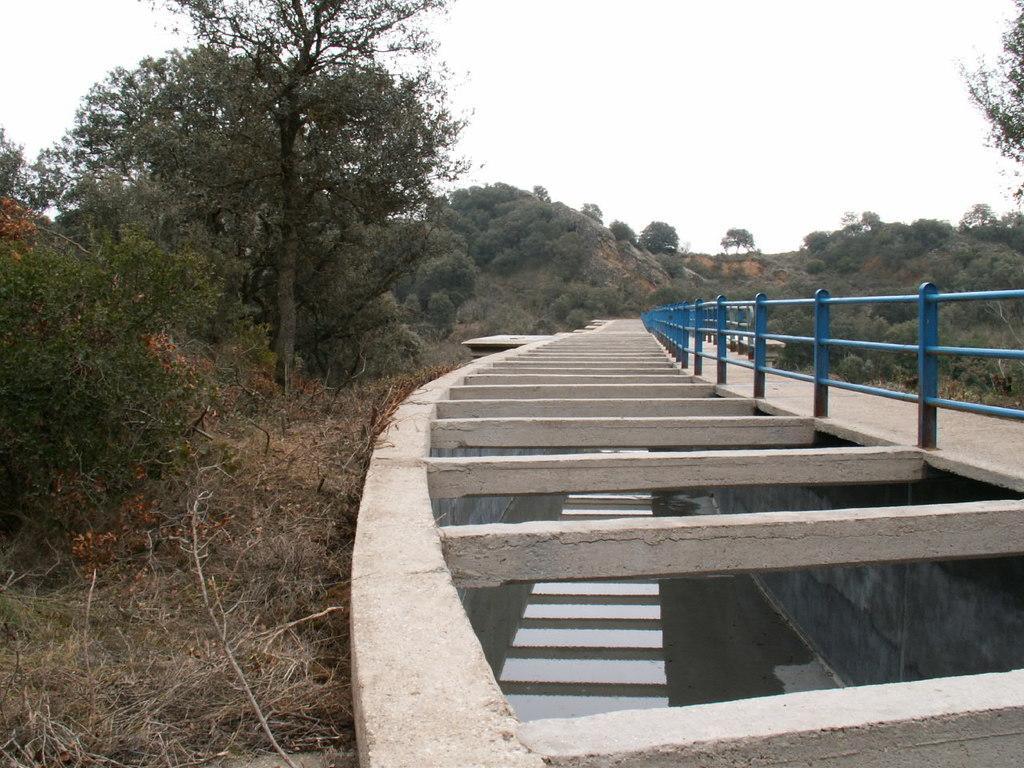Can you describe this image briefly? In this image I can see the bridge and the railing. I can see the water and the grass. In the background there are many trees, clouds and the sky. 